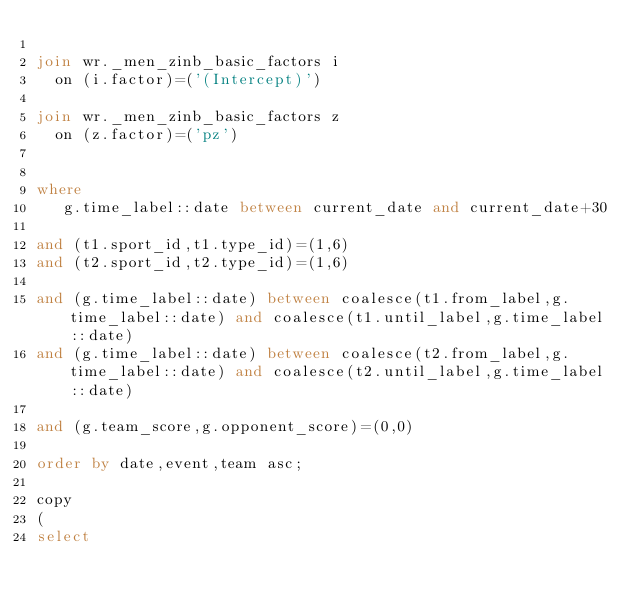Convert code to text. <code><loc_0><loc_0><loc_500><loc_500><_SQL_>
join wr._men_zinb_basic_factors i
  on (i.factor)=('(Intercept)')

join wr._men_zinb_basic_factors z
  on (z.factor)=('pz')


where
   g.time_label::date between current_date and current_date+30

and (t1.sport_id,t1.type_id)=(1,6)
and (t2.sport_id,t2.type_id)=(1,6)

and (g.time_label::date) between coalesce(t1.from_label,g.time_label::date) and coalesce(t1.until_label,g.time_label::date)
and (g.time_label::date) between coalesce(t2.from_label,g.time_label::date) and coalesce(t2.until_label,g.time_label::date)

and (g.team_score,g.opponent_score)=(0,0)

order by date,event,team asc;

copy
(
select
</code> 